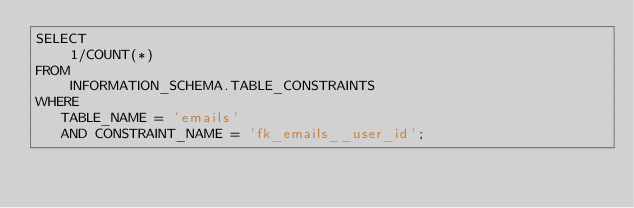<code> <loc_0><loc_0><loc_500><loc_500><_SQL_>SELECT
    1/COUNT(*)
FROM
    INFORMATION_SCHEMA.TABLE_CONSTRAINTS
WHERE
   TABLE_NAME = 'emails'
   AND CONSTRAINT_NAME = 'fk_emails__user_id';
</code> 